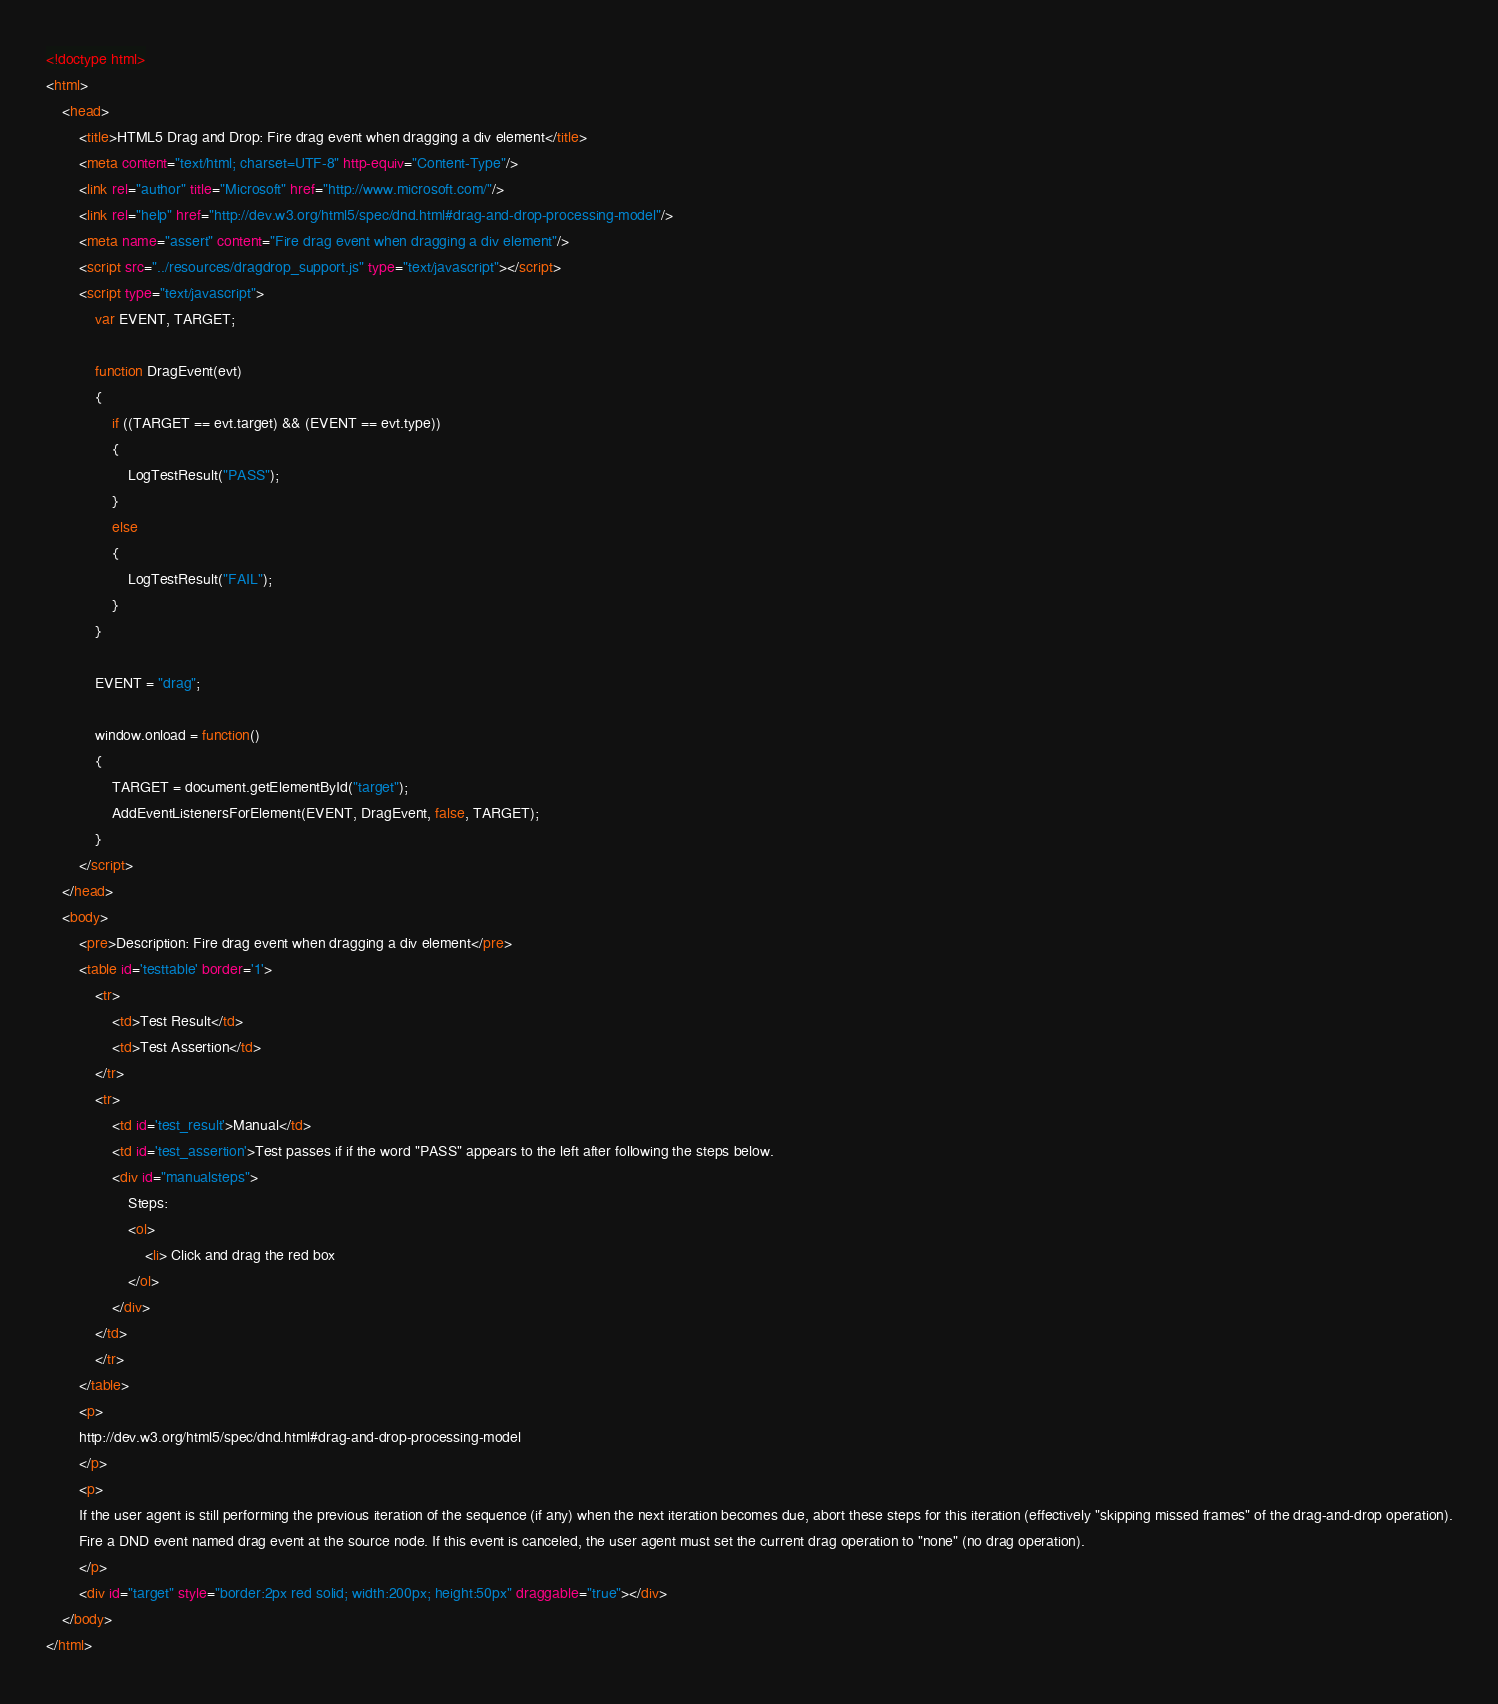<code> <loc_0><loc_0><loc_500><loc_500><_HTML_><!doctype html>
<html>
    <head>
        <title>HTML5 Drag and Drop: Fire drag event when dragging a div element</title>
        <meta content="text/html; charset=UTF-8" http-equiv="Content-Type"/>
        <link rel="author" title="Microsoft" href="http://www.microsoft.com/"/>
        <link rel="help" href="http://dev.w3.org/html5/spec/dnd.html#drag-and-drop-processing-model"/>
        <meta name="assert" content="Fire drag event when dragging a div element"/>
        <script src="../resources/dragdrop_support.js" type="text/javascript"></script>
        <script type="text/javascript">
            var EVENT, TARGET;

            function DragEvent(evt)
            {
                if ((TARGET == evt.target) && (EVENT == evt.type))
                {
                    LogTestResult("PASS");
                }
                else
                {
                    LogTestResult("FAIL");
                }
            }

            EVENT = "drag";

            window.onload = function()
            {
                TARGET = document.getElementById("target");
                AddEventListenersForElement(EVENT, DragEvent, false, TARGET);
            }
        </script>
    </head>
    <body>
        <pre>Description: Fire drag event when dragging a div element</pre>
        <table id='testtable' border='1'>
            <tr>
                <td>Test Result</td>
                <td>Test Assertion</td>
            </tr>
            <tr>
                <td id='test_result'>Manual</td>
                <td id='test_assertion'>Test passes if if the word "PASS" appears to the left after following the steps below.
                <div id="manualsteps">
                    Steps:
                    <ol>
                        <li> Click and drag the red box
                    </ol>
                </div>
            </td>
            </tr>
        </table>
        <p>
        http://dev.w3.org/html5/spec/dnd.html#drag-and-drop-processing-model
        </p>
        <p>
        If the user agent is still performing the previous iteration of the sequence (if any) when the next iteration becomes due, abort these steps for this iteration (effectively "skipping missed frames" of the drag-and-drop operation).
        Fire a DND event named drag event at the source node. If this event is canceled, the user agent must set the current drag operation to "none" (no drag operation).
        </p>
        <div id="target" style="border:2px red solid; width:200px; height:50px" draggable="true"></div>
    </body>
</html>
</code> 